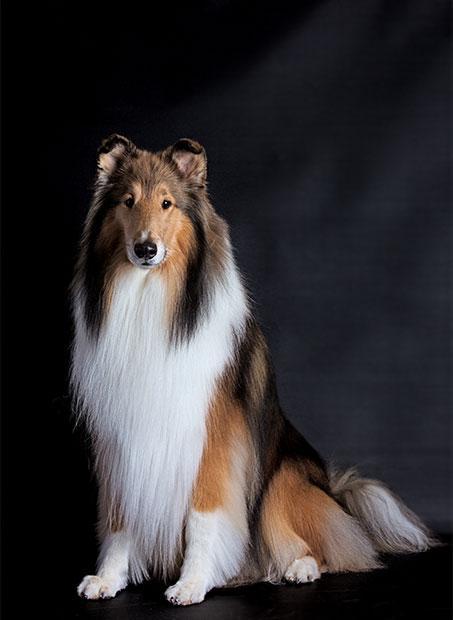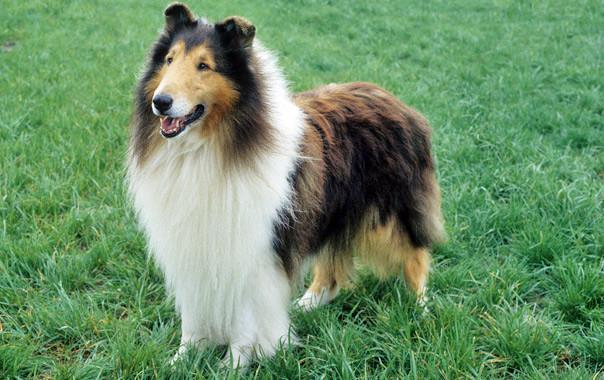The first image is the image on the left, the second image is the image on the right. Given the left and right images, does the statement "There are more then one collie on the right image" hold true? Answer yes or no. No. 